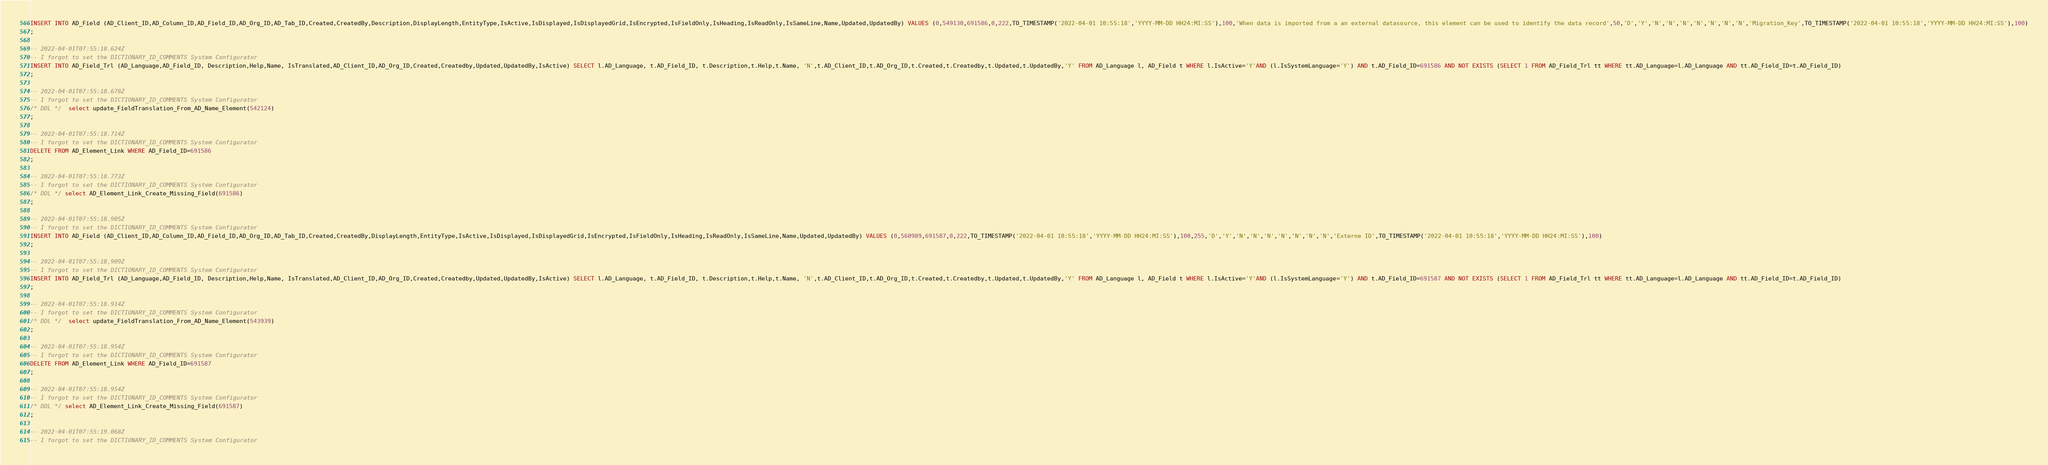<code> <loc_0><loc_0><loc_500><loc_500><_SQL_>INSERT INTO AD_Field (AD_Client_ID,AD_Column_ID,AD_Field_ID,AD_Org_ID,AD_Tab_ID,Created,CreatedBy,Description,DisplayLength,EntityType,IsActive,IsDisplayed,IsDisplayedGrid,IsEncrypted,IsFieldOnly,IsHeading,IsReadOnly,IsSameLine,Name,Updated,UpdatedBy) VALUES (0,549130,691586,0,222,TO_TIMESTAMP('2022-04-01 10:55:18','YYYY-MM-DD HH24:MI:SS'),100,'When data is imported from a an external datasource, this element can be used to identify the data record',50,'D','Y','N','N','N','N','N','N','N','Migration_Key',TO_TIMESTAMP('2022-04-01 10:55:18','YYYY-MM-DD HH24:MI:SS'),100)
;

-- 2022-04-01T07:55:18.624Z
-- I forgot to set the DICTIONARY_ID_COMMENTS System Configurator
INSERT INTO AD_Field_Trl (AD_Language,AD_Field_ID, Description,Help,Name, IsTranslated,AD_Client_ID,AD_Org_ID,Created,Createdby,Updated,UpdatedBy,IsActive) SELECT l.AD_Language, t.AD_Field_ID, t.Description,t.Help,t.Name, 'N',t.AD_Client_ID,t.AD_Org_ID,t.Created,t.Createdby,t.Updated,t.UpdatedBy,'Y' FROM AD_Language l, AD_Field t WHERE l.IsActive='Y'AND (l.IsSystemLanguage='Y') AND t.AD_Field_ID=691586 AND NOT EXISTS (SELECT 1 FROM AD_Field_Trl tt WHERE tt.AD_Language=l.AD_Language AND tt.AD_Field_ID=t.AD_Field_ID)
;

-- 2022-04-01T07:55:18.678Z
-- I forgot to set the DICTIONARY_ID_COMMENTS System Configurator
/* DDL */  select update_FieldTranslation_From_AD_Name_Element(542124) 
;

-- 2022-04-01T07:55:18.714Z
-- I forgot to set the DICTIONARY_ID_COMMENTS System Configurator
DELETE FROM AD_Element_Link WHERE AD_Field_ID=691586
;

-- 2022-04-01T07:55:18.773Z
-- I forgot to set the DICTIONARY_ID_COMMENTS System Configurator
/* DDL */ select AD_Element_Link_Create_Missing_Field(691586)
;

-- 2022-04-01T07:55:18.905Z
-- I forgot to set the DICTIONARY_ID_COMMENTS System Configurator
INSERT INTO AD_Field (AD_Client_ID,AD_Column_ID,AD_Field_ID,AD_Org_ID,AD_Tab_ID,Created,CreatedBy,DisplayLength,EntityType,IsActive,IsDisplayed,IsDisplayedGrid,IsEncrypted,IsFieldOnly,IsHeading,IsReadOnly,IsSameLine,Name,Updated,UpdatedBy) VALUES (0,560989,691587,0,222,TO_TIMESTAMP('2022-04-01 10:55:18','YYYY-MM-DD HH24:MI:SS'),100,255,'D','Y','N','N','N','N','N','N','N','Externe ID',TO_TIMESTAMP('2022-04-01 10:55:18','YYYY-MM-DD HH24:MI:SS'),100)
;

-- 2022-04-01T07:55:18.909Z
-- I forgot to set the DICTIONARY_ID_COMMENTS System Configurator
INSERT INTO AD_Field_Trl (AD_Language,AD_Field_ID, Description,Help,Name, IsTranslated,AD_Client_ID,AD_Org_ID,Created,Createdby,Updated,UpdatedBy,IsActive) SELECT l.AD_Language, t.AD_Field_ID, t.Description,t.Help,t.Name, 'N',t.AD_Client_ID,t.AD_Org_ID,t.Created,t.Createdby,t.Updated,t.UpdatedBy,'Y' FROM AD_Language l, AD_Field t WHERE l.IsActive='Y'AND (l.IsSystemLanguage='Y') AND t.AD_Field_ID=691587 AND NOT EXISTS (SELECT 1 FROM AD_Field_Trl tt WHERE tt.AD_Language=l.AD_Language AND tt.AD_Field_ID=t.AD_Field_ID)
;

-- 2022-04-01T07:55:18.914Z
-- I forgot to set the DICTIONARY_ID_COMMENTS System Configurator
/* DDL */  select update_FieldTranslation_From_AD_Name_Element(543939) 
;

-- 2022-04-01T07:55:18.954Z
-- I forgot to set the DICTIONARY_ID_COMMENTS System Configurator
DELETE FROM AD_Element_Link WHERE AD_Field_ID=691587
;

-- 2022-04-01T07:55:18.954Z
-- I forgot to set the DICTIONARY_ID_COMMENTS System Configurator
/* DDL */ select AD_Element_Link_Create_Missing_Field(691587)
;

-- 2022-04-01T07:55:19.068Z
-- I forgot to set the DICTIONARY_ID_COMMENTS System Configurator</code> 